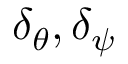Convert formula to latex. <formula><loc_0><loc_0><loc_500><loc_500>\delta _ { \theta } , \delta _ { \psi }</formula> 